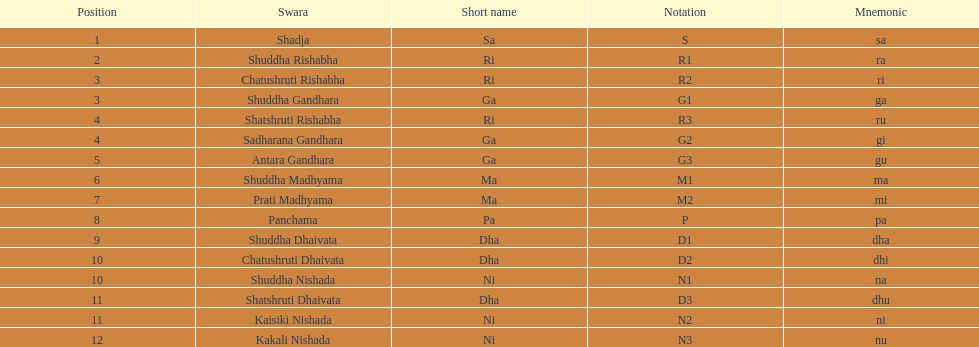How many swaras don't possess dhaivata in their designation? 13. 